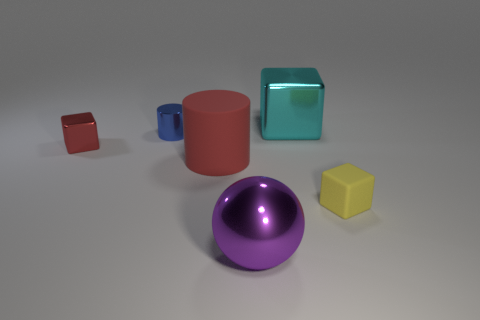There is a object that is the same color as the big rubber cylinder; what size is it?
Your answer should be compact. Small. There is a big thing that is the same color as the small metal cube; what is it made of?
Make the answer very short. Rubber. Does the tiny blue thing behind the purple sphere have the same material as the large ball?
Offer a terse response. Yes. How many other objects are there of the same material as the small blue cylinder?
Offer a terse response. 3. What is the material of the red thing that is the same size as the cyan metallic cube?
Provide a short and direct response. Rubber. Is the shape of the rubber object that is behind the yellow thing the same as the tiny shiny object to the right of the red metallic block?
Ensure brevity in your answer.  Yes. There is a purple object that is the same size as the red matte thing; what is its shape?
Offer a very short reply. Sphere. Is the large thing on the right side of the big ball made of the same material as the tiny object on the right side of the large metallic sphere?
Provide a succinct answer. No. There is a shiny object that is in front of the yellow block; is there a small metallic block that is on the left side of it?
Give a very brief answer. Yes. What is the color of the large cube that is made of the same material as the purple sphere?
Your answer should be very brief. Cyan. 